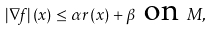Convert formula to latex. <formula><loc_0><loc_0><loc_500><loc_500>\ \left | \nabla f \right | \left ( x \right ) \leq \alpha r \left ( x \right ) + \beta \text { on } M ,</formula> 